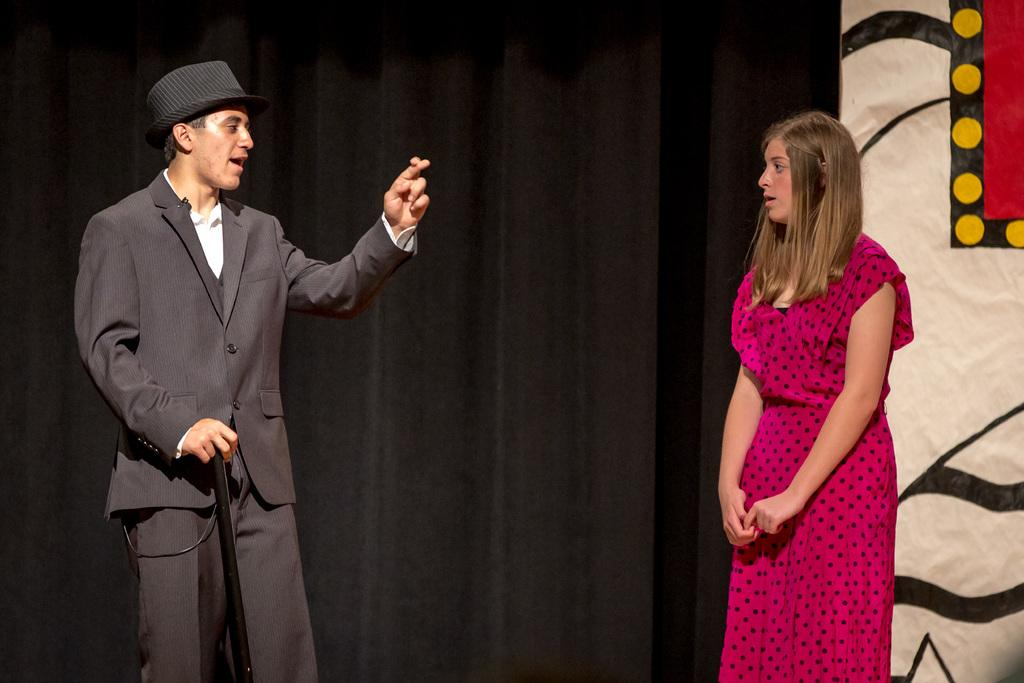How many people are present in the image? There is a man and a woman present in the image. What are the man and woman doing in the image? The man and woman are standing and talking in the image. What can be seen in the background of the image? There is a curtain visible in the image. What type of setting is depicted in the image? The scene appears to be a stage show. What type of cake is being served on the marble table in the image? There is no cake or marble table present in the image. 